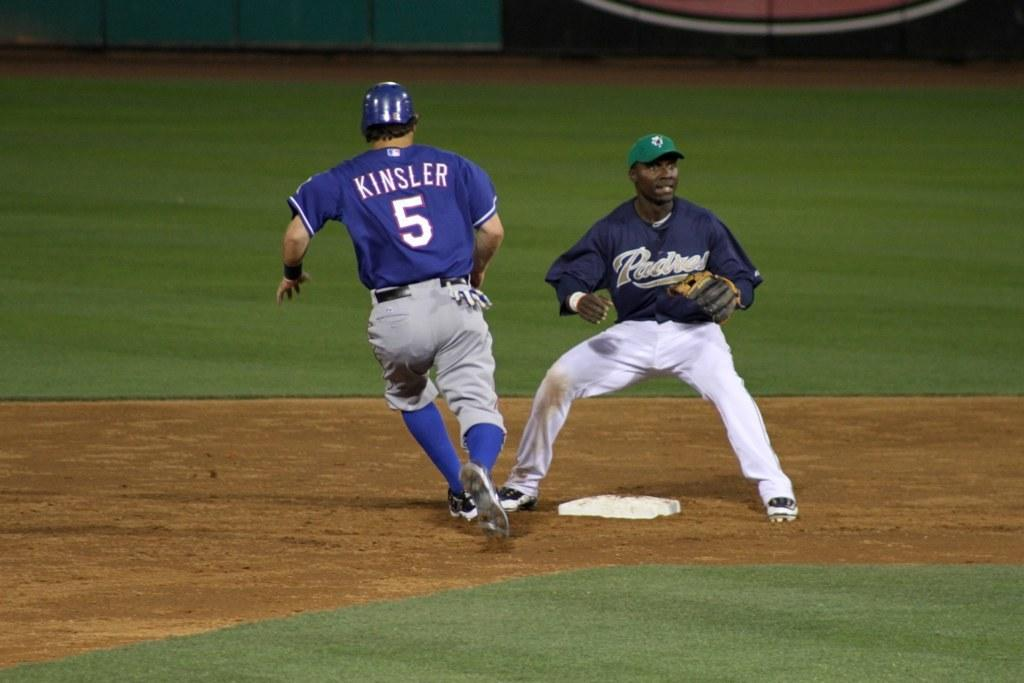<image>
Render a clear and concise summary of the photo. A baseball player with the number 5 on his back running past another player 